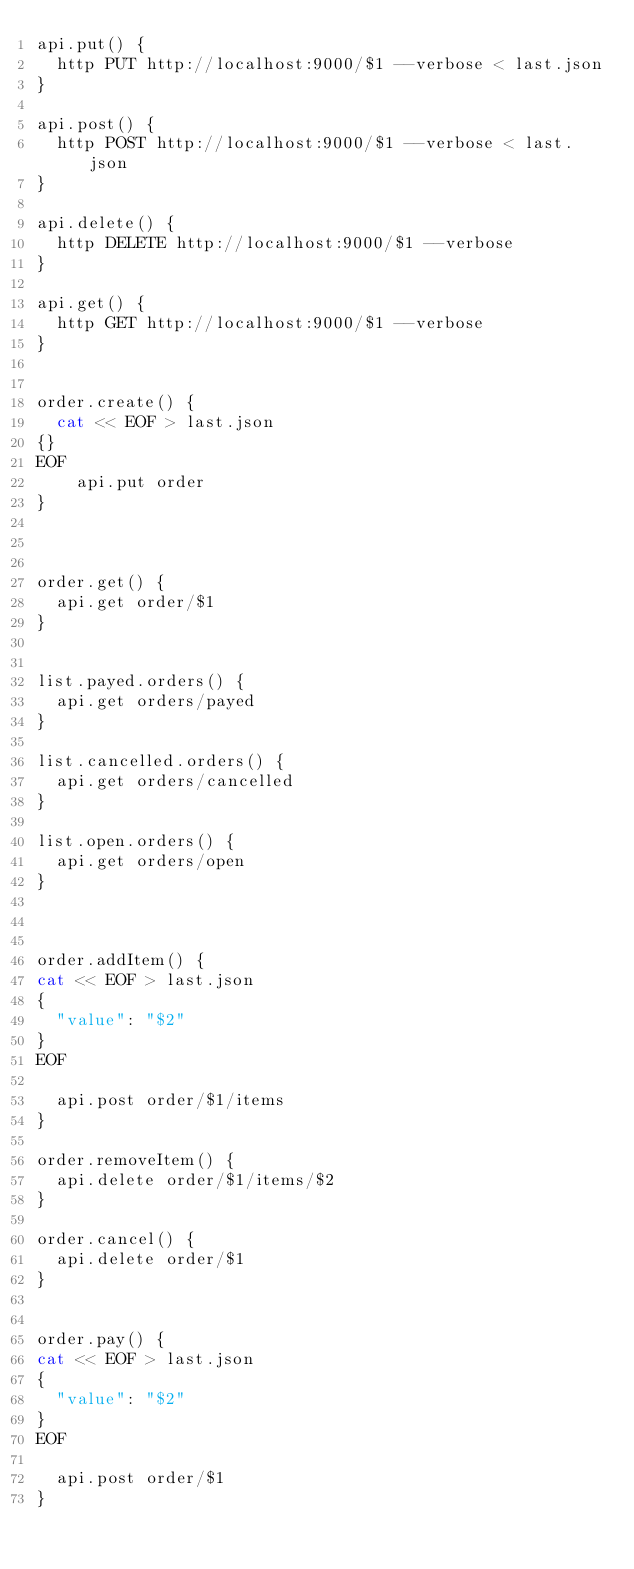<code> <loc_0><loc_0><loc_500><loc_500><_Bash_>api.put() {
  http PUT http://localhost:9000/$1 --verbose < last.json
}

api.post() {
  http POST http://localhost:9000/$1 --verbose < last.json
}

api.delete() {
  http DELETE http://localhost:9000/$1 --verbose
}

api.get() {
  http GET http://localhost:9000/$1 --verbose
}


order.create() {
  cat << EOF > last.json
{}
EOF
    api.put order
}



order.get() {
  api.get order/$1
}


list.payed.orders() {
  api.get orders/payed
}

list.cancelled.orders() {
  api.get orders/cancelled
}

list.open.orders() {
  api.get orders/open
}



order.addItem() {
cat << EOF > last.json
{
  "value": "$2"
}
EOF

  api.post order/$1/items
}

order.removeItem() {
  api.delete order/$1/items/$2
}

order.cancel() {
  api.delete order/$1
}


order.pay() {
cat << EOF > last.json
{
  "value": "$2"
}
EOF

  api.post order/$1
}</code> 